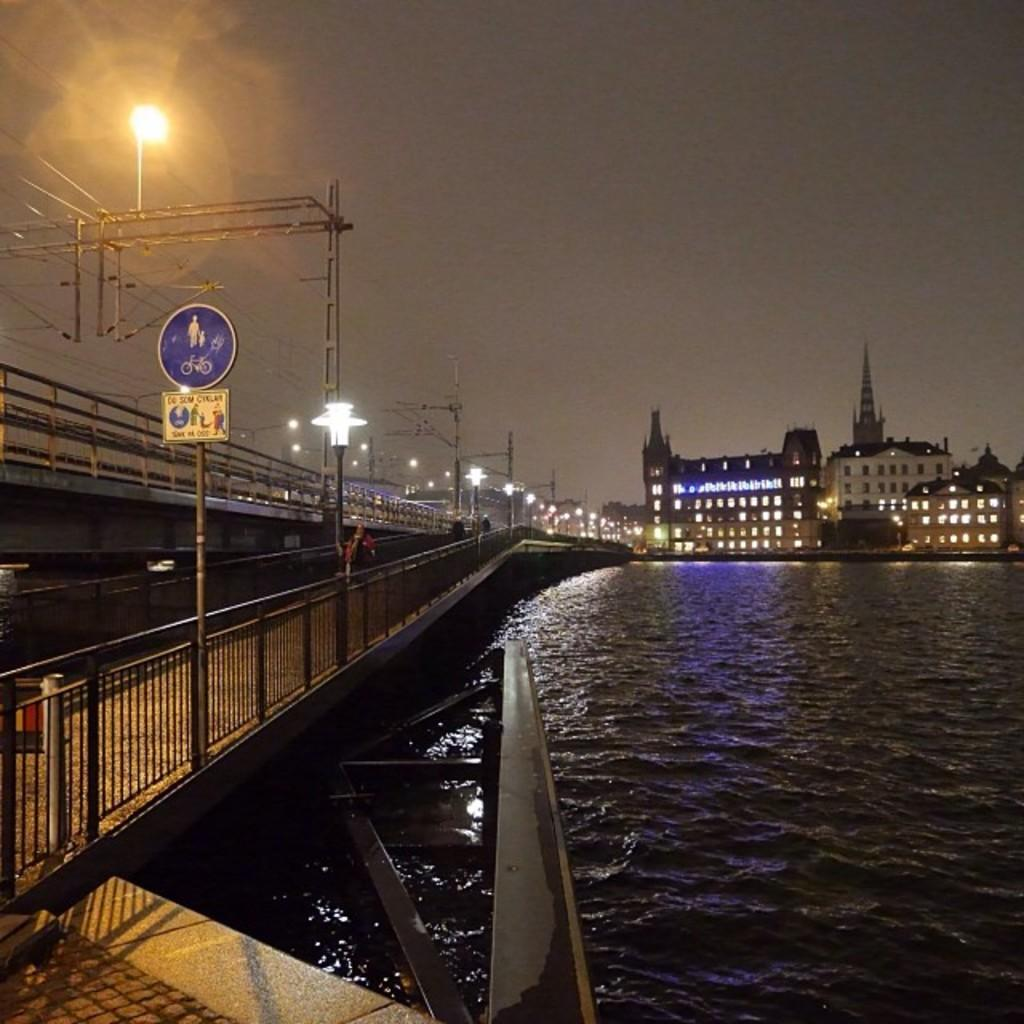What is the main feature of the image? There is water in the image. What structure can be seen crossing the water? There is a bridge in the image. Are there any people present in the image? Yes, there are persons in the image. What else can be seen in the image besides the water and bridge? There are buildings, lights, and poles in the image. What is visible in the background of the image? The sky is visible in the image. Can you tell me how many planes are flying over the water in the image? There are no planes visible in the image; it only features a bridge crossing the water. What type of flock is swimming in the water in the image? There are no animals or flocks present in the image; it only features a bridge crossing the water. 